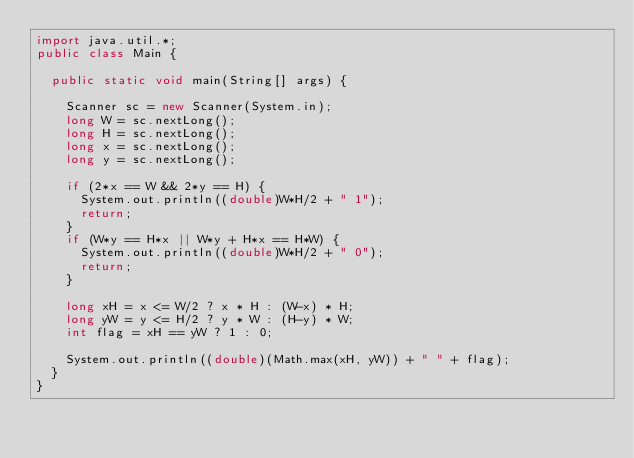Convert code to text. <code><loc_0><loc_0><loc_500><loc_500><_Java_>import java.util.*;
public class Main {
  
  public static void main(String[] args) {

    Scanner sc = new Scanner(System.in);
    long W = sc.nextLong();
    long H = sc.nextLong();
    long x = sc.nextLong();
    long y = sc.nextLong();
    
    if (2*x == W && 2*y == H) {
      System.out.println((double)W*H/2 + " 1");
      return;
    }
    if (W*y == H*x || W*y + H*x == H*W) {
      System.out.println((double)W*H/2 + " 0");
      return;
    }

    long xH = x <= W/2 ? x * H : (W-x) * H;
    long yW = y <= H/2 ? y * W : (H-y) * W;
    int flag = xH == yW ? 1 : 0;

    System.out.println((double)(Math.max(xH, yW)) + " " + flag);
  }
}
</code> 